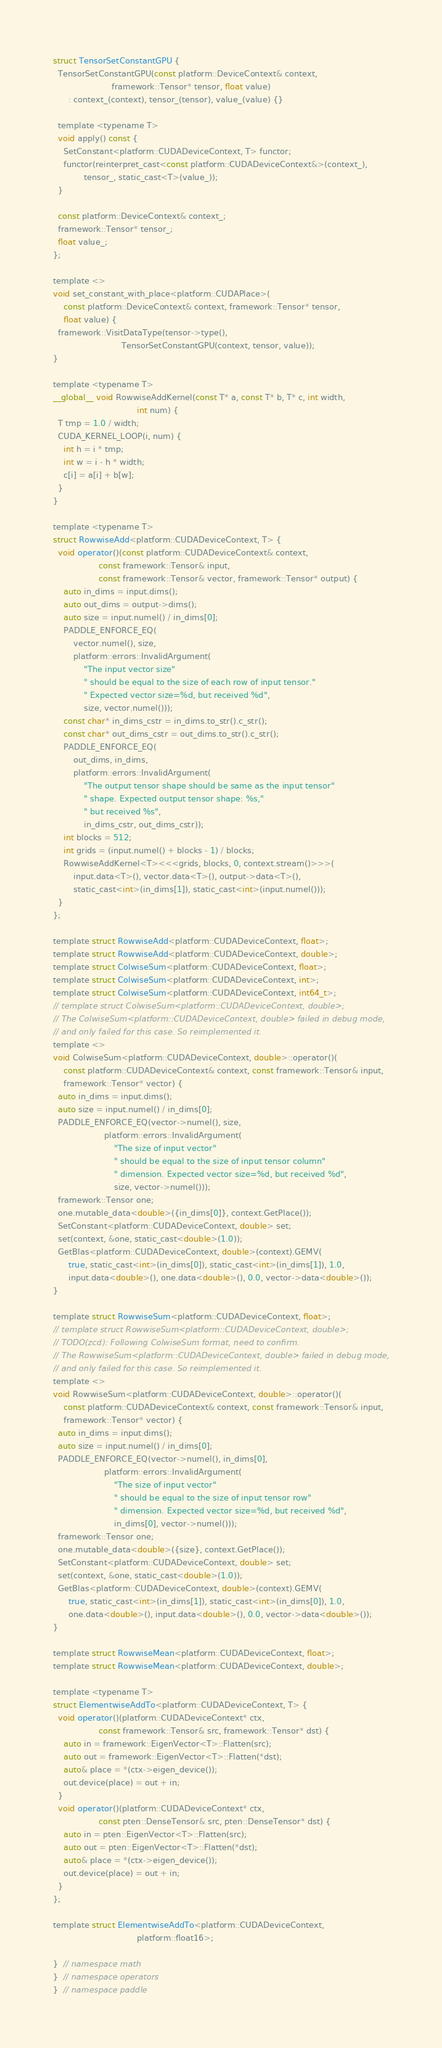Convert code to text. <code><loc_0><loc_0><loc_500><loc_500><_Cuda_>
struct TensorSetConstantGPU {
  TensorSetConstantGPU(const platform::DeviceContext& context,
                       framework::Tensor* tensor, float value)
      : context_(context), tensor_(tensor), value_(value) {}

  template <typename T>
  void apply() const {
    SetConstant<platform::CUDADeviceContext, T> functor;
    functor(reinterpret_cast<const platform::CUDADeviceContext&>(context_),
            tensor_, static_cast<T>(value_));
  }

  const platform::DeviceContext& context_;
  framework::Tensor* tensor_;
  float value_;
};

template <>
void set_constant_with_place<platform::CUDAPlace>(
    const platform::DeviceContext& context, framework::Tensor* tensor,
    float value) {
  framework::VisitDataType(tensor->type(),
                           TensorSetConstantGPU(context, tensor, value));
}

template <typename T>
__global__ void RowwiseAddKernel(const T* a, const T* b, T* c, int width,
                                 int num) {
  T tmp = 1.0 / width;
  CUDA_KERNEL_LOOP(i, num) {
    int h = i * tmp;
    int w = i - h * width;
    c[i] = a[i] + b[w];
  }
}

template <typename T>
struct RowwiseAdd<platform::CUDADeviceContext, T> {
  void operator()(const platform::CUDADeviceContext& context,
                  const framework::Tensor& input,
                  const framework::Tensor& vector, framework::Tensor* output) {
    auto in_dims = input.dims();
    auto out_dims = output->dims();
    auto size = input.numel() / in_dims[0];
    PADDLE_ENFORCE_EQ(
        vector.numel(), size,
        platform::errors::InvalidArgument(
            "The input vector size"
            " should be equal to the size of each row of input tensor."
            " Expected vector size=%d, but received %d",
            size, vector.numel()));
    const char* in_dims_cstr = in_dims.to_str().c_str();
    const char* out_dims_cstr = out_dims.to_str().c_str();
    PADDLE_ENFORCE_EQ(
        out_dims, in_dims,
        platform::errors::InvalidArgument(
            "The output tensor shape should be same as the input tensor"
            " shape. Expected output tensor shape: %s,"
            " but received %s",
            in_dims_cstr, out_dims_cstr));
    int blocks = 512;
    int grids = (input.numel() + blocks - 1) / blocks;
    RowwiseAddKernel<T><<<grids, blocks, 0, context.stream()>>>(
        input.data<T>(), vector.data<T>(), output->data<T>(),
        static_cast<int>(in_dims[1]), static_cast<int>(input.numel()));
  }
};

template struct RowwiseAdd<platform::CUDADeviceContext, float>;
template struct RowwiseAdd<platform::CUDADeviceContext, double>;
template struct ColwiseSum<platform::CUDADeviceContext, float>;
template struct ColwiseSum<platform::CUDADeviceContext, int>;
template struct ColwiseSum<platform::CUDADeviceContext, int64_t>;
// template struct ColwiseSum<platform::CUDADeviceContext, double>;
// The ColwiseSum<platform::CUDADeviceContext, double> failed in debug mode,
// and only failed for this case. So reimplemented it.
template <>
void ColwiseSum<platform::CUDADeviceContext, double>::operator()(
    const platform::CUDADeviceContext& context, const framework::Tensor& input,
    framework::Tensor* vector) {
  auto in_dims = input.dims();
  auto size = input.numel() / in_dims[0];
  PADDLE_ENFORCE_EQ(vector->numel(), size,
                    platform::errors::InvalidArgument(
                        "The size of input vector"
                        " should be equal to the size of input tensor column"
                        " dimension. Expected vector size=%d, but received %d",
                        size, vector->numel()));
  framework::Tensor one;
  one.mutable_data<double>({in_dims[0]}, context.GetPlace());
  SetConstant<platform::CUDADeviceContext, double> set;
  set(context, &one, static_cast<double>(1.0));
  GetBlas<platform::CUDADeviceContext, double>(context).GEMV(
      true, static_cast<int>(in_dims[0]), static_cast<int>(in_dims[1]), 1.0,
      input.data<double>(), one.data<double>(), 0.0, vector->data<double>());
}

template struct RowwiseSum<platform::CUDADeviceContext, float>;
// template struct RowwiseSum<platform::CUDADeviceContext, double>;
// TODO(zcd): Following ColwiseSum format, need to confirm.
// The RowwiseSum<platform::CUDADeviceContext, double> failed in debug mode,
// and only failed for this case. So reimplemented it.
template <>
void RowwiseSum<platform::CUDADeviceContext, double>::operator()(
    const platform::CUDADeviceContext& context, const framework::Tensor& input,
    framework::Tensor* vector) {
  auto in_dims = input.dims();
  auto size = input.numel() / in_dims[0];
  PADDLE_ENFORCE_EQ(vector->numel(), in_dims[0],
                    platform::errors::InvalidArgument(
                        "The size of input vector"
                        " should be equal to the size of input tensor row"
                        " dimension. Expected vector size=%d, but received %d",
                        in_dims[0], vector->numel()));
  framework::Tensor one;
  one.mutable_data<double>({size}, context.GetPlace());
  SetConstant<platform::CUDADeviceContext, double> set;
  set(context, &one, static_cast<double>(1.0));
  GetBlas<platform::CUDADeviceContext, double>(context).GEMV(
      true, static_cast<int>(in_dims[1]), static_cast<int>(in_dims[0]), 1.0,
      one.data<double>(), input.data<double>(), 0.0, vector->data<double>());
}

template struct RowwiseMean<platform::CUDADeviceContext, float>;
template struct RowwiseMean<platform::CUDADeviceContext, double>;

template <typename T>
struct ElementwiseAddTo<platform::CUDADeviceContext, T> {
  void operator()(platform::CUDADeviceContext* ctx,
                  const framework::Tensor& src, framework::Tensor* dst) {
    auto in = framework::EigenVector<T>::Flatten(src);
    auto out = framework::EigenVector<T>::Flatten(*dst);
    auto& place = *(ctx->eigen_device());
    out.device(place) = out + in;
  }
  void operator()(platform::CUDADeviceContext* ctx,
                  const pten::DenseTensor& src, pten::DenseTensor* dst) {
    auto in = pten::EigenVector<T>::Flatten(src);
    auto out = pten::EigenVector<T>::Flatten(*dst);
    auto& place = *(ctx->eigen_device());
    out.device(place) = out + in;
  }
};

template struct ElementwiseAddTo<platform::CUDADeviceContext,
                                 platform::float16>;

}  // namespace math
}  // namespace operators
}  // namespace paddle
</code> 